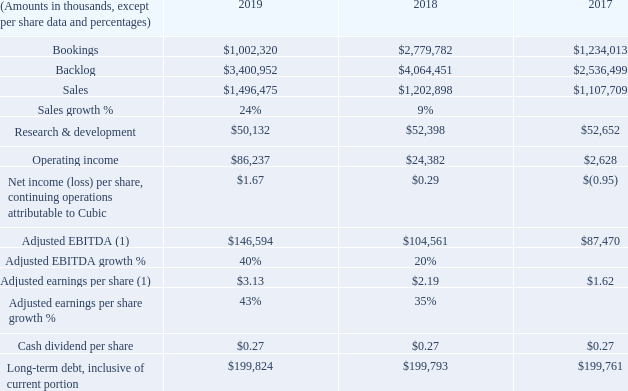Financial and Operating Highlights
CONTINUING OPERATIONS
(1) See reconciliation of GAAP to non-GAAP financial measures tables in Management’s Discussion and Analysis of Financial Condition and Results of Operations in the Form 10-K.
For the Adjusted EBITDA, where can the reconciliation of GAAP to non-GAAP financial measures tables be found? Management’s discussion and analysis of financial condition and results of operations in the form 10-k. What is the cash dividend per share in 2019? $0.27. What are the periods highlighted in the table? 2019, 2018, 2017. In which year is the adjusted earnings per share growth % larger? 43%>35%
Answer: 2019. What is the change in the adjusted EBITDA growth % from 2018 to 2019?
Answer scale should be: percent. 40%-20%
Answer: 20. What is the percentage change in adjusted EBITDA in 2019 from 2018?
Answer scale should be: percent. (146,594-104,561)/104,561
Answer: 40.2. 